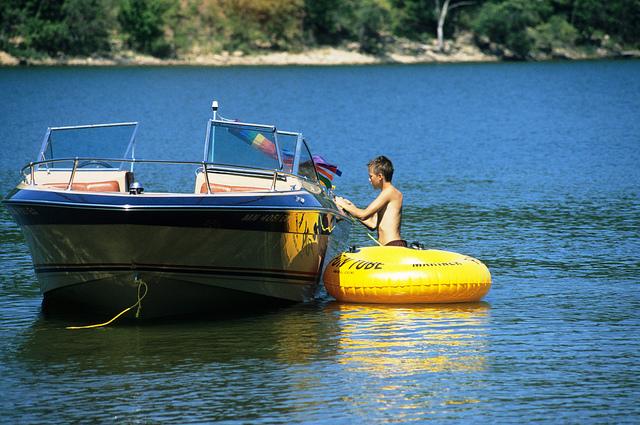Where is the boat going?
Be succinct. Nowhere. Is the photo taken in the United States?
Answer briefly. Yes. What is on the bottom of the boat?
Give a very brief answer. Water. What supplies does the boat have?
Quick response, please. None. Are they having a party?
Concise answer only. No. Is the water calm?
Give a very brief answer. Yes. How could someone get out of the water?
Quick response, please. Climb. What is attached to the back of the boat?
Write a very short answer. Inner tube. 